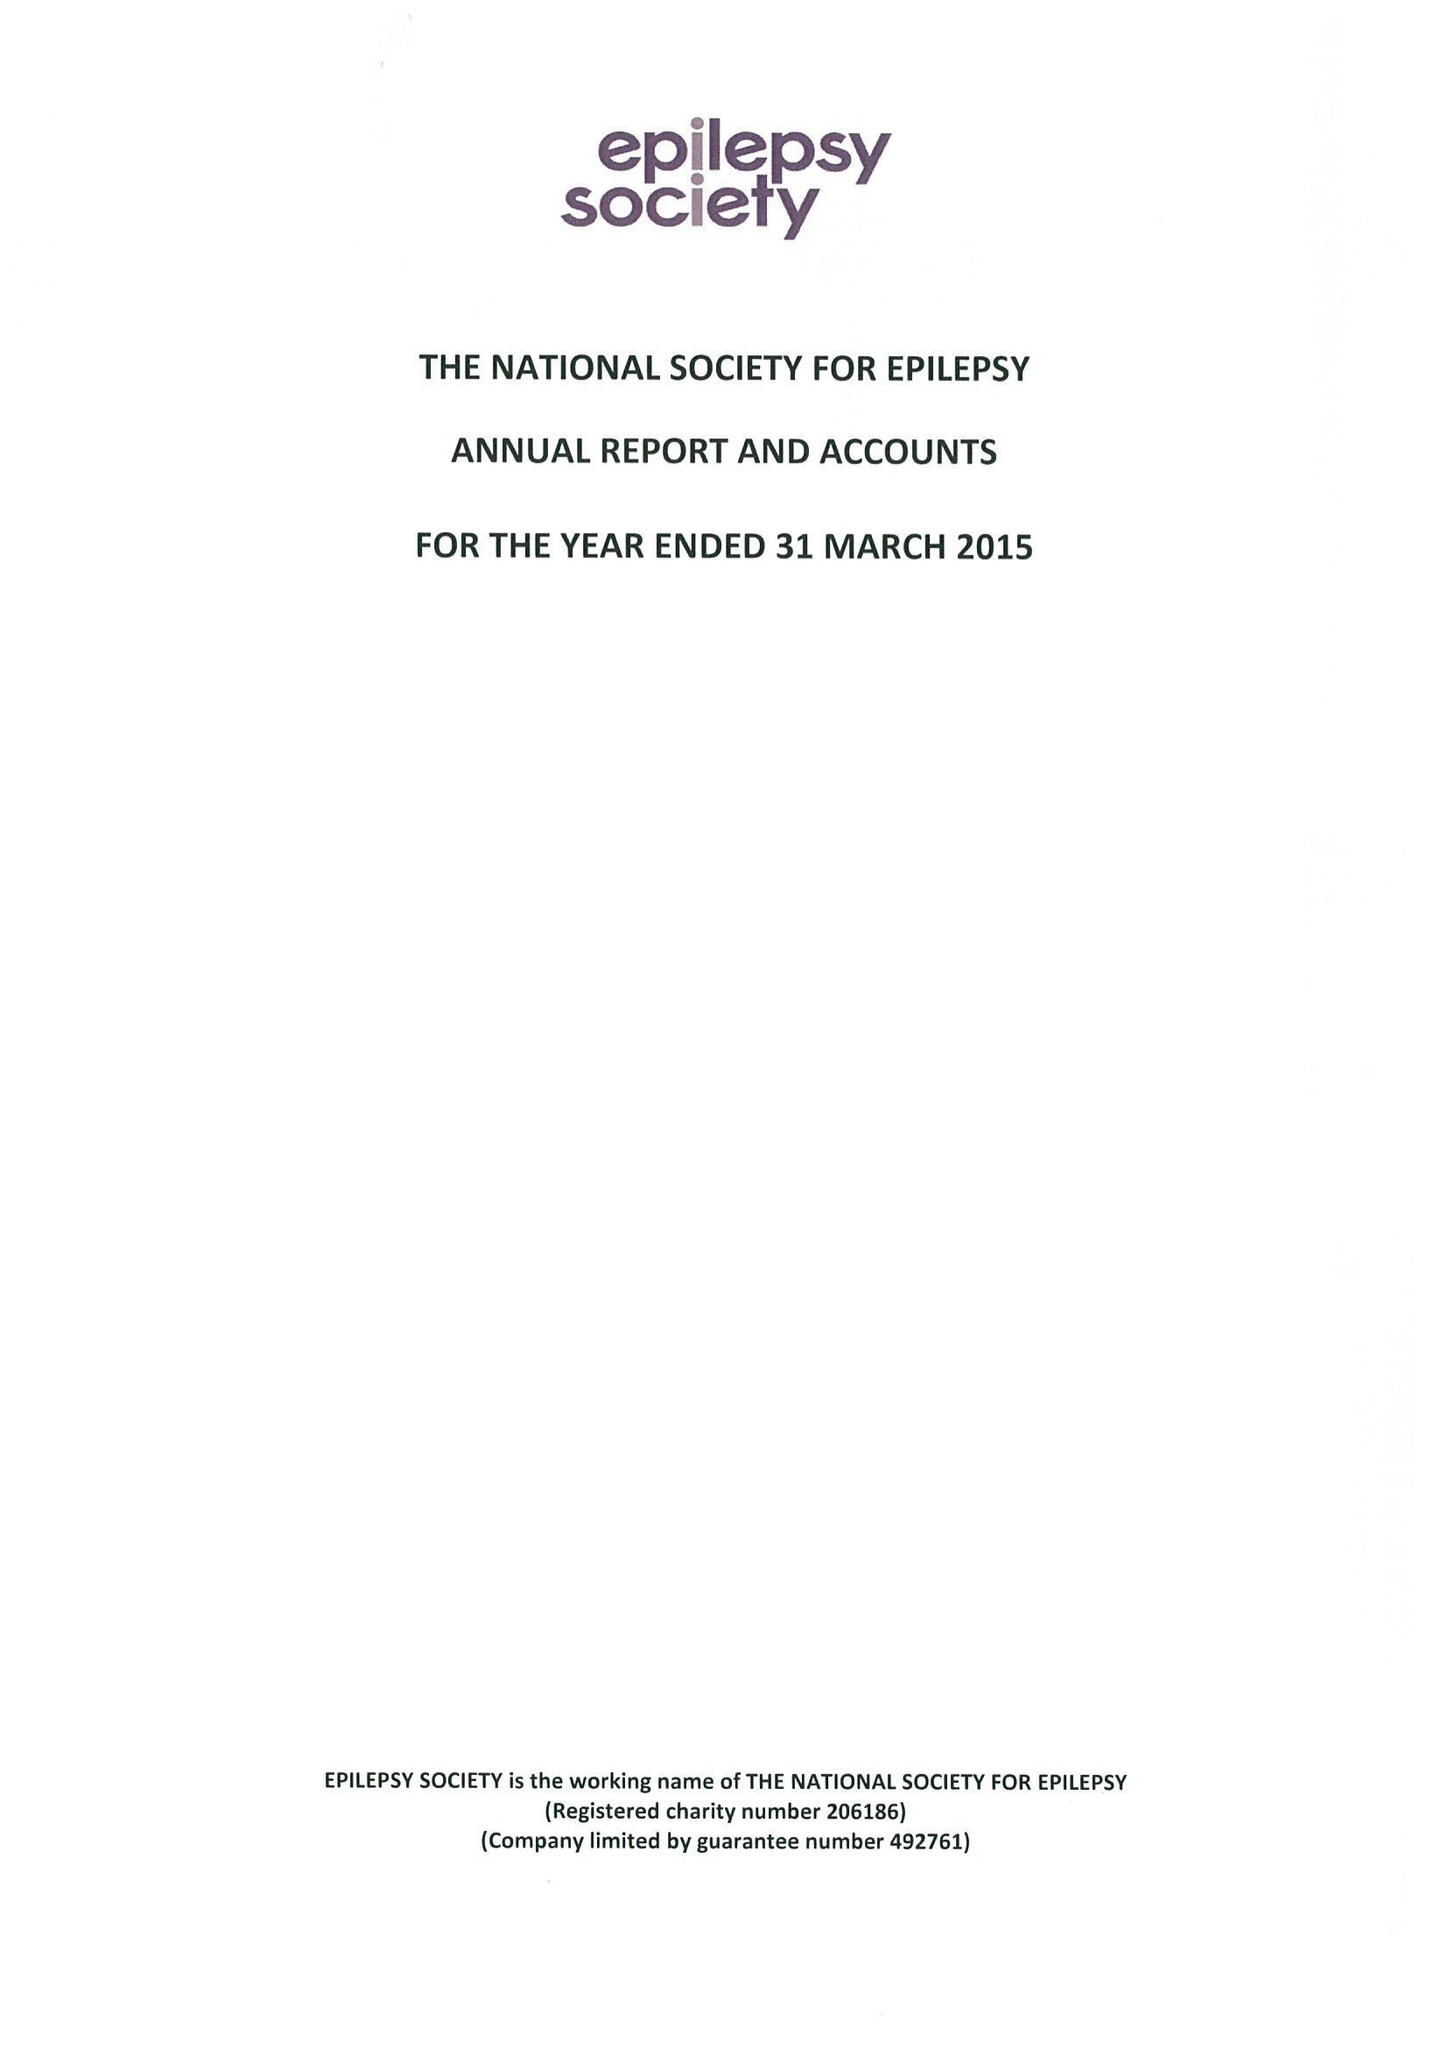What is the value for the charity_name?
Answer the question using a single word or phrase. Epilepsy Society 